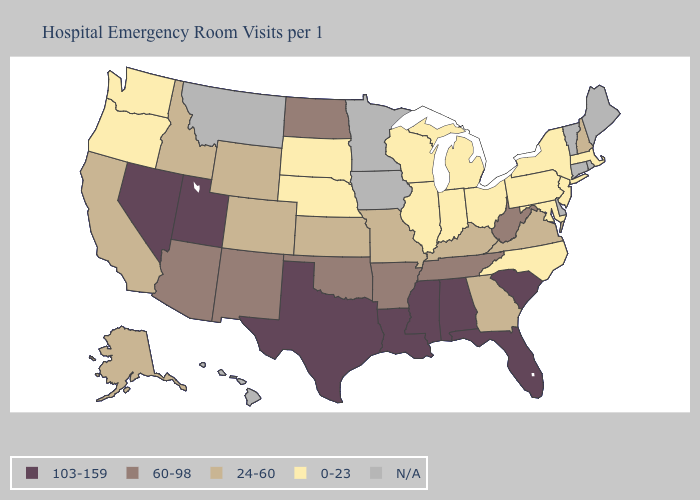What is the lowest value in states that border Kansas?
Write a very short answer. 0-23. What is the value of Indiana?
Write a very short answer. 0-23. Among the states that border Pennsylvania , does West Virginia have the highest value?
Keep it brief. Yes. Among the states that border Arizona , does Utah have the lowest value?
Keep it brief. No. Does Alabama have the highest value in the USA?
Keep it brief. Yes. Name the states that have a value in the range 24-60?
Quick response, please. Alaska, California, Colorado, Georgia, Idaho, Kansas, Kentucky, Missouri, New Hampshire, Virginia, Wyoming. What is the lowest value in states that border Oklahoma?
Answer briefly. 24-60. Name the states that have a value in the range 0-23?
Quick response, please. Illinois, Indiana, Maryland, Massachusetts, Michigan, Nebraska, New Jersey, New York, North Carolina, Ohio, Oregon, Pennsylvania, South Dakota, Washington, Wisconsin. Does Pennsylvania have the lowest value in the USA?
Write a very short answer. Yes. What is the value of Colorado?
Short answer required. 24-60. Does the map have missing data?
Concise answer only. Yes. What is the value of Pennsylvania?
Be succinct. 0-23. Is the legend a continuous bar?
Answer briefly. No. Among the states that border Wyoming , which have the highest value?
Write a very short answer. Utah. 